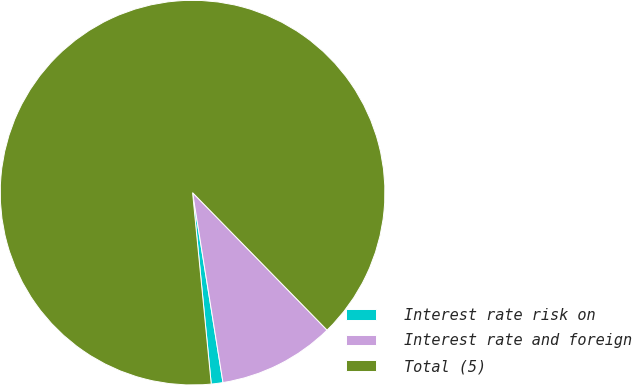<chart> <loc_0><loc_0><loc_500><loc_500><pie_chart><fcel>Interest rate risk on<fcel>Interest rate and foreign<fcel>Total (5)<nl><fcel>0.98%<fcel>9.8%<fcel>89.21%<nl></chart> 